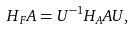<formula> <loc_0><loc_0><loc_500><loc_500>H _ { F } A = U ^ { - 1 } H _ { A } A U ,</formula> 